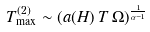<formula> <loc_0><loc_0><loc_500><loc_500>T ^ { ( 2 ) } _ { \max } \sim ( a ( H ) \, T \, \Omega ) ^ { \frac { 1 } { \alpha - 1 } }</formula> 